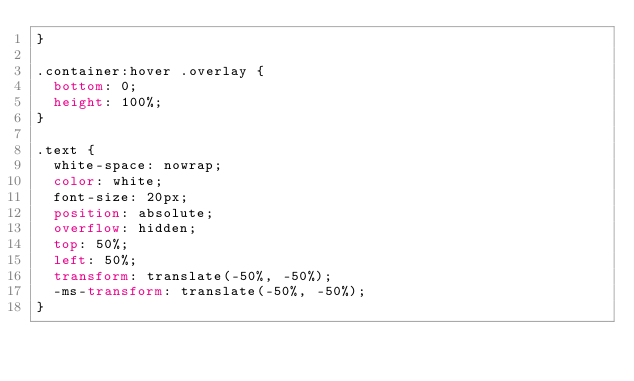Convert code to text. <code><loc_0><loc_0><loc_500><loc_500><_CSS_>}

.container:hover .overlay {
  bottom: 0;
  height: 100%;
}

.text {
  white-space: nowrap; 
  color: white;
  font-size: 20px;
  position: absolute;
  overflow: hidden;
  top: 50%;
  left: 50%;
  transform: translate(-50%, -50%);
  -ms-transform: translate(-50%, -50%);
}</code> 